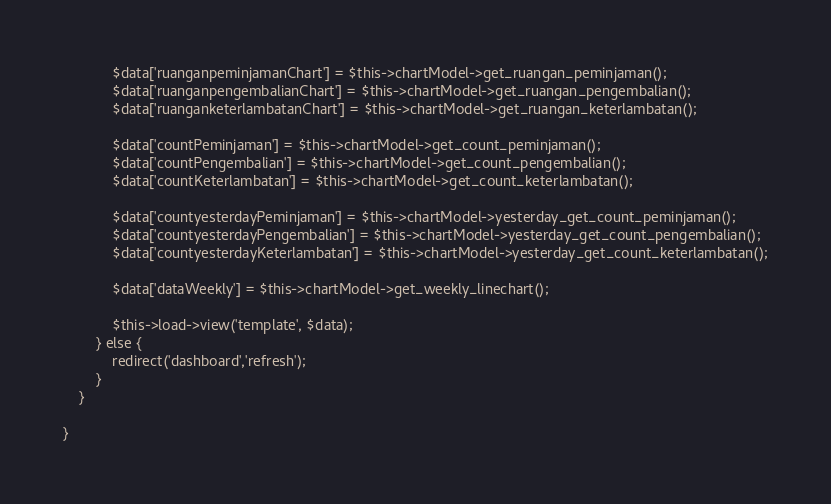<code> <loc_0><loc_0><loc_500><loc_500><_PHP_>            $data['ruanganpeminjamanChart'] = $this->chartModel->get_ruangan_peminjaman();
            $data['ruanganpengembalianChart'] = $this->chartModel->get_ruangan_pengembalian();
            $data['ruanganketerlambatanChart'] = $this->chartModel->get_ruangan_keterlambatan();

            $data['countPeminjaman'] = $this->chartModel->get_count_peminjaman();
            $data['countPengembalian'] = $this->chartModel->get_count_pengembalian();
            $data['countKeterlambatan'] = $this->chartModel->get_count_keterlambatan();

            $data['countyesterdayPeminjaman'] = $this->chartModel->yesterday_get_count_peminjaman();
            $data['countyesterdayPengembalian'] = $this->chartModel->yesterday_get_count_pengembalian();
            $data['countyesterdayKeterlambatan'] = $this->chartModel->yesterday_get_count_keterlambatan();

            $data['dataWeekly'] = $this->chartModel->get_weekly_linechart();
            
            $this->load->view('template', $data);
        } else {
            redirect('dashboard','refresh');
        }
    }

}
</code> 